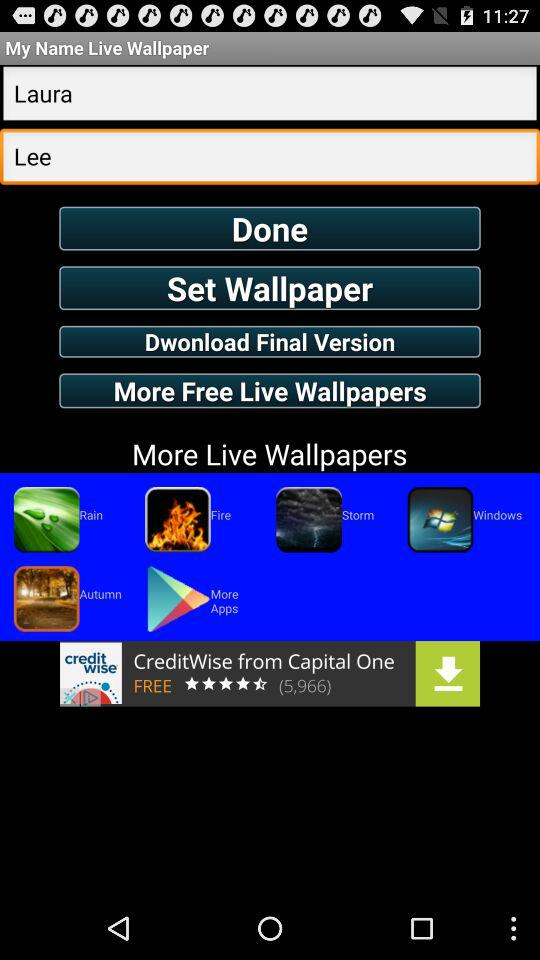What is the name of the user? The name of the user is "Laura Lee". 